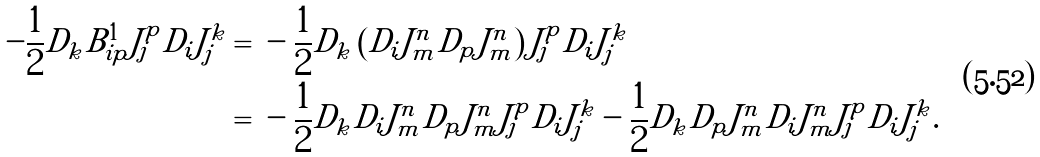Convert formula to latex. <formula><loc_0><loc_0><loc_500><loc_500>- \frac { 1 } { 2 } D _ { k } B ^ { 1 } _ { i p } J _ { j } ^ { p } D _ { i } J _ { j } ^ { k } = & \ - \frac { 1 } { 2 } D _ { k } \left ( D _ { i } J _ { m } ^ { n } D _ { p } J _ { m } ^ { n } \right ) J _ { j } ^ { p } D _ { i } J _ { j } ^ { k } \\ = & \ - \frac { 1 } { 2 } D _ { k } D _ { i } J _ { m } ^ { n } D _ { p } J _ { m } ^ { n } J _ { j } ^ { p } D _ { i } J _ { j } ^ { k } - \frac { 1 } { 2 } D _ { k } D _ { p } J _ { m } ^ { n } D _ { i } J _ { m } ^ { n } J _ { j } ^ { p } D _ { i } J _ { j } ^ { k } .</formula> 